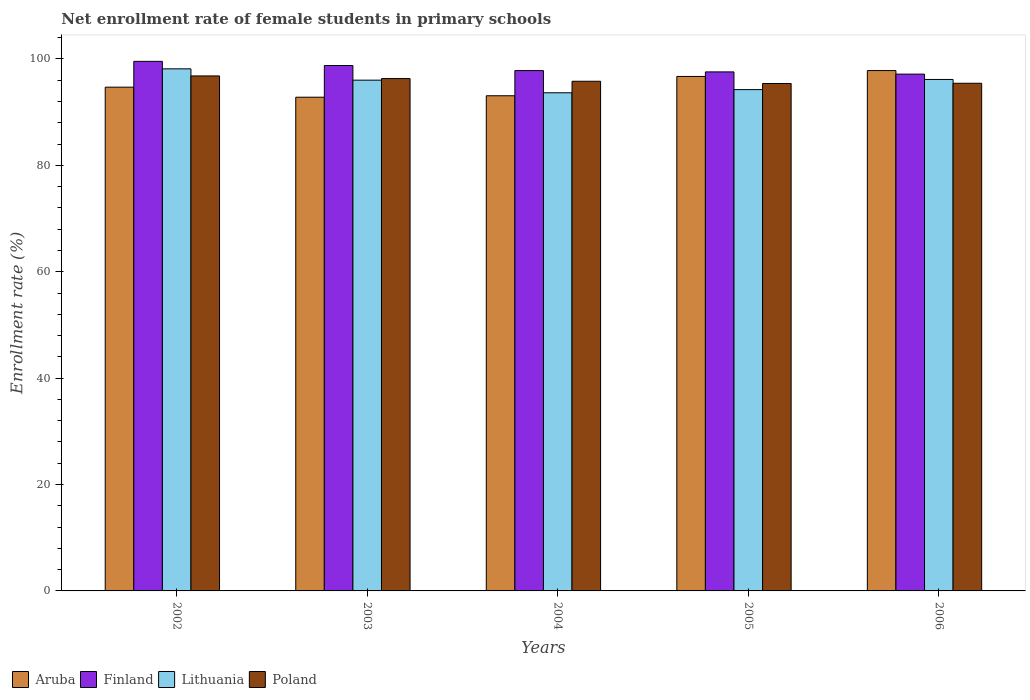How many different coloured bars are there?
Provide a short and direct response. 4. How many groups of bars are there?
Your answer should be compact. 5. Are the number of bars per tick equal to the number of legend labels?
Provide a succinct answer. Yes. Are the number of bars on each tick of the X-axis equal?
Provide a short and direct response. Yes. In how many cases, is the number of bars for a given year not equal to the number of legend labels?
Your answer should be compact. 0. What is the net enrollment rate of female students in primary schools in Poland in 2003?
Ensure brevity in your answer.  96.31. Across all years, what is the maximum net enrollment rate of female students in primary schools in Lithuania?
Give a very brief answer. 98.15. Across all years, what is the minimum net enrollment rate of female students in primary schools in Finland?
Give a very brief answer. 97.15. In which year was the net enrollment rate of female students in primary schools in Poland maximum?
Your response must be concise. 2002. In which year was the net enrollment rate of female students in primary schools in Aruba minimum?
Provide a succinct answer. 2003. What is the total net enrollment rate of female students in primary schools in Aruba in the graph?
Provide a short and direct response. 475.13. What is the difference between the net enrollment rate of female students in primary schools in Poland in 2004 and that in 2006?
Offer a terse response. 0.38. What is the difference between the net enrollment rate of female students in primary schools in Finland in 2003 and the net enrollment rate of female students in primary schools in Lithuania in 2006?
Offer a terse response. 2.62. What is the average net enrollment rate of female students in primary schools in Lithuania per year?
Offer a very short reply. 95.64. In the year 2005, what is the difference between the net enrollment rate of female students in primary schools in Aruba and net enrollment rate of female students in primary schools in Lithuania?
Make the answer very short. 2.48. In how many years, is the net enrollment rate of female students in primary schools in Finland greater than 20 %?
Your response must be concise. 5. What is the ratio of the net enrollment rate of female students in primary schools in Poland in 2004 to that in 2006?
Provide a succinct answer. 1. Is the net enrollment rate of female students in primary schools in Finland in 2002 less than that in 2006?
Provide a succinct answer. No. What is the difference between the highest and the second highest net enrollment rate of female students in primary schools in Finland?
Make the answer very short. 0.79. What is the difference between the highest and the lowest net enrollment rate of female students in primary schools in Finland?
Your answer should be very brief. 2.4. Is the sum of the net enrollment rate of female students in primary schools in Finland in 2002 and 2003 greater than the maximum net enrollment rate of female students in primary schools in Lithuania across all years?
Make the answer very short. Yes. Is it the case that in every year, the sum of the net enrollment rate of female students in primary schools in Aruba and net enrollment rate of female students in primary schools in Finland is greater than the sum of net enrollment rate of female students in primary schools in Poland and net enrollment rate of female students in primary schools in Lithuania?
Make the answer very short. Yes. What does the 1st bar from the left in 2005 represents?
Give a very brief answer. Aruba. Is it the case that in every year, the sum of the net enrollment rate of female students in primary schools in Lithuania and net enrollment rate of female students in primary schools in Aruba is greater than the net enrollment rate of female students in primary schools in Finland?
Keep it short and to the point. Yes. How many bars are there?
Your response must be concise. 20. What is the difference between two consecutive major ticks on the Y-axis?
Keep it short and to the point. 20. Does the graph contain grids?
Keep it short and to the point. No. Where does the legend appear in the graph?
Keep it short and to the point. Bottom left. How are the legend labels stacked?
Give a very brief answer. Horizontal. What is the title of the graph?
Your response must be concise. Net enrollment rate of female students in primary schools. Does "Equatorial Guinea" appear as one of the legend labels in the graph?
Provide a succinct answer. No. What is the label or title of the X-axis?
Make the answer very short. Years. What is the label or title of the Y-axis?
Offer a very short reply. Enrollment rate (%). What is the Enrollment rate (%) in Aruba in 2002?
Provide a short and direct response. 94.7. What is the Enrollment rate (%) of Finland in 2002?
Your answer should be very brief. 99.55. What is the Enrollment rate (%) of Lithuania in 2002?
Ensure brevity in your answer.  98.15. What is the Enrollment rate (%) of Poland in 2002?
Your response must be concise. 96.81. What is the Enrollment rate (%) of Aruba in 2003?
Offer a very short reply. 92.81. What is the Enrollment rate (%) of Finland in 2003?
Keep it short and to the point. 98.77. What is the Enrollment rate (%) of Lithuania in 2003?
Give a very brief answer. 96.02. What is the Enrollment rate (%) in Poland in 2003?
Offer a very short reply. 96.31. What is the Enrollment rate (%) of Aruba in 2004?
Offer a terse response. 93.08. What is the Enrollment rate (%) of Finland in 2004?
Offer a very short reply. 97.82. What is the Enrollment rate (%) in Lithuania in 2004?
Make the answer very short. 93.65. What is the Enrollment rate (%) of Poland in 2004?
Your answer should be very brief. 95.81. What is the Enrollment rate (%) in Aruba in 2005?
Your answer should be compact. 96.72. What is the Enrollment rate (%) in Finland in 2005?
Make the answer very short. 97.57. What is the Enrollment rate (%) of Lithuania in 2005?
Ensure brevity in your answer.  94.24. What is the Enrollment rate (%) in Poland in 2005?
Provide a succinct answer. 95.39. What is the Enrollment rate (%) of Aruba in 2006?
Your answer should be very brief. 97.82. What is the Enrollment rate (%) of Finland in 2006?
Your answer should be very brief. 97.15. What is the Enrollment rate (%) of Lithuania in 2006?
Provide a succinct answer. 96.15. What is the Enrollment rate (%) in Poland in 2006?
Provide a succinct answer. 95.43. Across all years, what is the maximum Enrollment rate (%) in Aruba?
Ensure brevity in your answer.  97.82. Across all years, what is the maximum Enrollment rate (%) in Finland?
Provide a succinct answer. 99.55. Across all years, what is the maximum Enrollment rate (%) of Lithuania?
Provide a succinct answer. 98.15. Across all years, what is the maximum Enrollment rate (%) in Poland?
Provide a short and direct response. 96.81. Across all years, what is the minimum Enrollment rate (%) of Aruba?
Give a very brief answer. 92.81. Across all years, what is the minimum Enrollment rate (%) in Finland?
Ensure brevity in your answer.  97.15. Across all years, what is the minimum Enrollment rate (%) of Lithuania?
Keep it short and to the point. 93.65. Across all years, what is the minimum Enrollment rate (%) in Poland?
Give a very brief answer. 95.39. What is the total Enrollment rate (%) in Aruba in the graph?
Provide a short and direct response. 475.13. What is the total Enrollment rate (%) in Finland in the graph?
Offer a terse response. 490.86. What is the total Enrollment rate (%) of Lithuania in the graph?
Your response must be concise. 478.19. What is the total Enrollment rate (%) in Poland in the graph?
Your answer should be very brief. 479.76. What is the difference between the Enrollment rate (%) in Aruba in 2002 and that in 2003?
Make the answer very short. 1.89. What is the difference between the Enrollment rate (%) of Finland in 2002 and that in 2003?
Your answer should be very brief. 0.79. What is the difference between the Enrollment rate (%) of Lithuania in 2002 and that in 2003?
Your answer should be compact. 2.13. What is the difference between the Enrollment rate (%) of Poland in 2002 and that in 2003?
Ensure brevity in your answer.  0.5. What is the difference between the Enrollment rate (%) of Aruba in 2002 and that in 2004?
Your answer should be compact. 1.62. What is the difference between the Enrollment rate (%) of Finland in 2002 and that in 2004?
Make the answer very short. 1.74. What is the difference between the Enrollment rate (%) of Lithuania in 2002 and that in 2004?
Make the answer very short. 4.5. What is the difference between the Enrollment rate (%) of Aruba in 2002 and that in 2005?
Offer a very short reply. -2.02. What is the difference between the Enrollment rate (%) of Finland in 2002 and that in 2005?
Make the answer very short. 1.98. What is the difference between the Enrollment rate (%) of Lithuania in 2002 and that in 2005?
Give a very brief answer. 3.91. What is the difference between the Enrollment rate (%) of Poland in 2002 and that in 2005?
Ensure brevity in your answer.  1.42. What is the difference between the Enrollment rate (%) in Aruba in 2002 and that in 2006?
Your response must be concise. -3.12. What is the difference between the Enrollment rate (%) in Finland in 2002 and that in 2006?
Provide a succinct answer. 2.4. What is the difference between the Enrollment rate (%) in Lithuania in 2002 and that in 2006?
Ensure brevity in your answer.  2. What is the difference between the Enrollment rate (%) in Poland in 2002 and that in 2006?
Keep it short and to the point. 1.38. What is the difference between the Enrollment rate (%) in Aruba in 2003 and that in 2004?
Your answer should be compact. -0.27. What is the difference between the Enrollment rate (%) in Finland in 2003 and that in 2004?
Give a very brief answer. 0.95. What is the difference between the Enrollment rate (%) of Lithuania in 2003 and that in 2004?
Provide a succinct answer. 2.37. What is the difference between the Enrollment rate (%) in Poland in 2003 and that in 2004?
Make the answer very short. 0.5. What is the difference between the Enrollment rate (%) of Aruba in 2003 and that in 2005?
Keep it short and to the point. -3.9. What is the difference between the Enrollment rate (%) of Finland in 2003 and that in 2005?
Your answer should be compact. 1.2. What is the difference between the Enrollment rate (%) in Lithuania in 2003 and that in 2005?
Provide a short and direct response. 1.78. What is the difference between the Enrollment rate (%) of Poland in 2003 and that in 2005?
Make the answer very short. 0.92. What is the difference between the Enrollment rate (%) in Aruba in 2003 and that in 2006?
Make the answer very short. -5.01. What is the difference between the Enrollment rate (%) in Finland in 2003 and that in 2006?
Provide a succinct answer. 1.61. What is the difference between the Enrollment rate (%) in Lithuania in 2003 and that in 2006?
Give a very brief answer. -0.13. What is the difference between the Enrollment rate (%) in Poland in 2003 and that in 2006?
Keep it short and to the point. 0.88. What is the difference between the Enrollment rate (%) of Aruba in 2004 and that in 2005?
Your answer should be very brief. -3.63. What is the difference between the Enrollment rate (%) of Finland in 2004 and that in 2005?
Provide a succinct answer. 0.24. What is the difference between the Enrollment rate (%) in Lithuania in 2004 and that in 2005?
Offer a very short reply. -0.59. What is the difference between the Enrollment rate (%) of Poland in 2004 and that in 2005?
Give a very brief answer. 0.42. What is the difference between the Enrollment rate (%) of Aruba in 2004 and that in 2006?
Make the answer very short. -4.74. What is the difference between the Enrollment rate (%) of Finland in 2004 and that in 2006?
Your answer should be compact. 0.66. What is the difference between the Enrollment rate (%) of Lithuania in 2004 and that in 2006?
Your answer should be very brief. -2.5. What is the difference between the Enrollment rate (%) in Poland in 2004 and that in 2006?
Your response must be concise. 0.38. What is the difference between the Enrollment rate (%) of Aruba in 2005 and that in 2006?
Keep it short and to the point. -1.1. What is the difference between the Enrollment rate (%) of Finland in 2005 and that in 2006?
Provide a short and direct response. 0.42. What is the difference between the Enrollment rate (%) in Lithuania in 2005 and that in 2006?
Provide a succinct answer. -1.91. What is the difference between the Enrollment rate (%) in Poland in 2005 and that in 2006?
Offer a very short reply. -0.04. What is the difference between the Enrollment rate (%) in Aruba in 2002 and the Enrollment rate (%) in Finland in 2003?
Give a very brief answer. -4.07. What is the difference between the Enrollment rate (%) in Aruba in 2002 and the Enrollment rate (%) in Lithuania in 2003?
Keep it short and to the point. -1.32. What is the difference between the Enrollment rate (%) in Aruba in 2002 and the Enrollment rate (%) in Poland in 2003?
Keep it short and to the point. -1.61. What is the difference between the Enrollment rate (%) in Finland in 2002 and the Enrollment rate (%) in Lithuania in 2003?
Your response must be concise. 3.54. What is the difference between the Enrollment rate (%) in Finland in 2002 and the Enrollment rate (%) in Poland in 2003?
Offer a terse response. 3.24. What is the difference between the Enrollment rate (%) in Lithuania in 2002 and the Enrollment rate (%) in Poland in 2003?
Your response must be concise. 1.83. What is the difference between the Enrollment rate (%) of Aruba in 2002 and the Enrollment rate (%) of Finland in 2004?
Provide a succinct answer. -3.12. What is the difference between the Enrollment rate (%) in Aruba in 2002 and the Enrollment rate (%) in Lithuania in 2004?
Your answer should be very brief. 1.05. What is the difference between the Enrollment rate (%) of Aruba in 2002 and the Enrollment rate (%) of Poland in 2004?
Keep it short and to the point. -1.11. What is the difference between the Enrollment rate (%) in Finland in 2002 and the Enrollment rate (%) in Lithuania in 2004?
Offer a terse response. 5.91. What is the difference between the Enrollment rate (%) in Finland in 2002 and the Enrollment rate (%) in Poland in 2004?
Give a very brief answer. 3.74. What is the difference between the Enrollment rate (%) in Lithuania in 2002 and the Enrollment rate (%) in Poland in 2004?
Ensure brevity in your answer.  2.33. What is the difference between the Enrollment rate (%) of Aruba in 2002 and the Enrollment rate (%) of Finland in 2005?
Your answer should be compact. -2.87. What is the difference between the Enrollment rate (%) of Aruba in 2002 and the Enrollment rate (%) of Lithuania in 2005?
Provide a short and direct response. 0.46. What is the difference between the Enrollment rate (%) in Aruba in 2002 and the Enrollment rate (%) in Poland in 2005?
Keep it short and to the point. -0.69. What is the difference between the Enrollment rate (%) of Finland in 2002 and the Enrollment rate (%) of Lithuania in 2005?
Offer a terse response. 5.31. What is the difference between the Enrollment rate (%) of Finland in 2002 and the Enrollment rate (%) of Poland in 2005?
Offer a terse response. 4.16. What is the difference between the Enrollment rate (%) in Lithuania in 2002 and the Enrollment rate (%) in Poland in 2005?
Offer a terse response. 2.76. What is the difference between the Enrollment rate (%) in Aruba in 2002 and the Enrollment rate (%) in Finland in 2006?
Give a very brief answer. -2.45. What is the difference between the Enrollment rate (%) in Aruba in 2002 and the Enrollment rate (%) in Lithuania in 2006?
Offer a terse response. -1.45. What is the difference between the Enrollment rate (%) in Aruba in 2002 and the Enrollment rate (%) in Poland in 2006?
Give a very brief answer. -0.73. What is the difference between the Enrollment rate (%) in Finland in 2002 and the Enrollment rate (%) in Lithuania in 2006?
Your answer should be very brief. 3.4. What is the difference between the Enrollment rate (%) of Finland in 2002 and the Enrollment rate (%) of Poland in 2006?
Your answer should be very brief. 4.12. What is the difference between the Enrollment rate (%) in Lithuania in 2002 and the Enrollment rate (%) in Poland in 2006?
Your answer should be compact. 2.71. What is the difference between the Enrollment rate (%) in Aruba in 2003 and the Enrollment rate (%) in Finland in 2004?
Your response must be concise. -5. What is the difference between the Enrollment rate (%) in Aruba in 2003 and the Enrollment rate (%) in Lithuania in 2004?
Offer a terse response. -0.83. What is the difference between the Enrollment rate (%) of Aruba in 2003 and the Enrollment rate (%) of Poland in 2004?
Offer a very short reply. -3. What is the difference between the Enrollment rate (%) of Finland in 2003 and the Enrollment rate (%) of Lithuania in 2004?
Provide a succinct answer. 5.12. What is the difference between the Enrollment rate (%) of Finland in 2003 and the Enrollment rate (%) of Poland in 2004?
Your answer should be very brief. 2.96. What is the difference between the Enrollment rate (%) of Lithuania in 2003 and the Enrollment rate (%) of Poland in 2004?
Keep it short and to the point. 0.2. What is the difference between the Enrollment rate (%) of Aruba in 2003 and the Enrollment rate (%) of Finland in 2005?
Your response must be concise. -4.76. What is the difference between the Enrollment rate (%) of Aruba in 2003 and the Enrollment rate (%) of Lithuania in 2005?
Provide a succinct answer. -1.43. What is the difference between the Enrollment rate (%) in Aruba in 2003 and the Enrollment rate (%) in Poland in 2005?
Offer a very short reply. -2.58. What is the difference between the Enrollment rate (%) in Finland in 2003 and the Enrollment rate (%) in Lithuania in 2005?
Your answer should be very brief. 4.53. What is the difference between the Enrollment rate (%) of Finland in 2003 and the Enrollment rate (%) of Poland in 2005?
Provide a short and direct response. 3.38. What is the difference between the Enrollment rate (%) in Lithuania in 2003 and the Enrollment rate (%) in Poland in 2005?
Keep it short and to the point. 0.63. What is the difference between the Enrollment rate (%) of Aruba in 2003 and the Enrollment rate (%) of Finland in 2006?
Your response must be concise. -4.34. What is the difference between the Enrollment rate (%) in Aruba in 2003 and the Enrollment rate (%) in Lithuania in 2006?
Your answer should be very brief. -3.34. What is the difference between the Enrollment rate (%) in Aruba in 2003 and the Enrollment rate (%) in Poland in 2006?
Your answer should be very brief. -2.62. What is the difference between the Enrollment rate (%) in Finland in 2003 and the Enrollment rate (%) in Lithuania in 2006?
Offer a terse response. 2.62. What is the difference between the Enrollment rate (%) in Finland in 2003 and the Enrollment rate (%) in Poland in 2006?
Give a very brief answer. 3.33. What is the difference between the Enrollment rate (%) of Lithuania in 2003 and the Enrollment rate (%) of Poland in 2006?
Offer a terse response. 0.58. What is the difference between the Enrollment rate (%) of Aruba in 2004 and the Enrollment rate (%) of Finland in 2005?
Your answer should be very brief. -4.49. What is the difference between the Enrollment rate (%) of Aruba in 2004 and the Enrollment rate (%) of Lithuania in 2005?
Keep it short and to the point. -1.15. What is the difference between the Enrollment rate (%) in Aruba in 2004 and the Enrollment rate (%) in Poland in 2005?
Make the answer very short. -2.31. What is the difference between the Enrollment rate (%) of Finland in 2004 and the Enrollment rate (%) of Lithuania in 2005?
Offer a terse response. 3.58. What is the difference between the Enrollment rate (%) in Finland in 2004 and the Enrollment rate (%) in Poland in 2005?
Make the answer very short. 2.43. What is the difference between the Enrollment rate (%) in Lithuania in 2004 and the Enrollment rate (%) in Poland in 2005?
Provide a succinct answer. -1.75. What is the difference between the Enrollment rate (%) of Aruba in 2004 and the Enrollment rate (%) of Finland in 2006?
Offer a very short reply. -4.07. What is the difference between the Enrollment rate (%) in Aruba in 2004 and the Enrollment rate (%) in Lithuania in 2006?
Offer a very short reply. -3.07. What is the difference between the Enrollment rate (%) of Aruba in 2004 and the Enrollment rate (%) of Poland in 2006?
Give a very brief answer. -2.35. What is the difference between the Enrollment rate (%) in Finland in 2004 and the Enrollment rate (%) in Lithuania in 2006?
Keep it short and to the point. 1.67. What is the difference between the Enrollment rate (%) in Finland in 2004 and the Enrollment rate (%) in Poland in 2006?
Your answer should be compact. 2.38. What is the difference between the Enrollment rate (%) in Lithuania in 2004 and the Enrollment rate (%) in Poland in 2006?
Your response must be concise. -1.79. What is the difference between the Enrollment rate (%) of Aruba in 2005 and the Enrollment rate (%) of Finland in 2006?
Offer a very short reply. -0.44. What is the difference between the Enrollment rate (%) in Aruba in 2005 and the Enrollment rate (%) in Lithuania in 2006?
Give a very brief answer. 0.57. What is the difference between the Enrollment rate (%) of Aruba in 2005 and the Enrollment rate (%) of Poland in 2006?
Make the answer very short. 1.28. What is the difference between the Enrollment rate (%) of Finland in 2005 and the Enrollment rate (%) of Lithuania in 2006?
Offer a very short reply. 1.42. What is the difference between the Enrollment rate (%) in Finland in 2005 and the Enrollment rate (%) in Poland in 2006?
Make the answer very short. 2.14. What is the difference between the Enrollment rate (%) in Lithuania in 2005 and the Enrollment rate (%) in Poland in 2006?
Your answer should be very brief. -1.2. What is the average Enrollment rate (%) of Aruba per year?
Provide a short and direct response. 95.03. What is the average Enrollment rate (%) in Finland per year?
Offer a terse response. 98.17. What is the average Enrollment rate (%) of Lithuania per year?
Offer a terse response. 95.64. What is the average Enrollment rate (%) of Poland per year?
Keep it short and to the point. 95.95. In the year 2002, what is the difference between the Enrollment rate (%) in Aruba and Enrollment rate (%) in Finland?
Make the answer very short. -4.85. In the year 2002, what is the difference between the Enrollment rate (%) of Aruba and Enrollment rate (%) of Lithuania?
Make the answer very short. -3.45. In the year 2002, what is the difference between the Enrollment rate (%) of Aruba and Enrollment rate (%) of Poland?
Provide a succinct answer. -2.11. In the year 2002, what is the difference between the Enrollment rate (%) of Finland and Enrollment rate (%) of Lithuania?
Give a very brief answer. 1.41. In the year 2002, what is the difference between the Enrollment rate (%) of Finland and Enrollment rate (%) of Poland?
Offer a very short reply. 2.74. In the year 2002, what is the difference between the Enrollment rate (%) of Lithuania and Enrollment rate (%) of Poland?
Your answer should be compact. 1.33. In the year 2003, what is the difference between the Enrollment rate (%) of Aruba and Enrollment rate (%) of Finland?
Provide a succinct answer. -5.95. In the year 2003, what is the difference between the Enrollment rate (%) of Aruba and Enrollment rate (%) of Lithuania?
Your answer should be compact. -3.2. In the year 2003, what is the difference between the Enrollment rate (%) in Aruba and Enrollment rate (%) in Poland?
Your response must be concise. -3.5. In the year 2003, what is the difference between the Enrollment rate (%) of Finland and Enrollment rate (%) of Lithuania?
Your answer should be compact. 2.75. In the year 2003, what is the difference between the Enrollment rate (%) of Finland and Enrollment rate (%) of Poland?
Ensure brevity in your answer.  2.45. In the year 2003, what is the difference between the Enrollment rate (%) in Lithuania and Enrollment rate (%) in Poland?
Keep it short and to the point. -0.3. In the year 2004, what is the difference between the Enrollment rate (%) of Aruba and Enrollment rate (%) of Finland?
Offer a very short reply. -4.73. In the year 2004, what is the difference between the Enrollment rate (%) of Aruba and Enrollment rate (%) of Lithuania?
Offer a very short reply. -0.56. In the year 2004, what is the difference between the Enrollment rate (%) of Aruba and Enrollment rate (%) of Poland?
Keep it short and to the point. -2.73. In the year 2004, what is the difference between the Enrollment rate (%) of Finland and Enrollment rate (%) of Lithuania?
Ensure brevity in your answer.  4.17. In the year 2004, what is the difference between the Enrollment rate (%) in Finland and Enrollment rate (%) in Poland?
Provide a succinct answer. 2. In the year 2004, what is the difference between the Enrollment rate (%) in Lithuania and Enrollment rate (%) in Poland?
Your response must be concise. -2.17. In the year 2005, what is the difference between the Enrollment rate (%) of Aruba and Enrollment rate (%) of Finland?
Ensure brevity in your answer.  -0.86. In the year 2005, what is the difference between the Enrollment rate (%) of Aruba and Enrollment rate (%) of Lithuania?
Ensure brevity in your answer.  2.48. In the year 2005, what is the difference between the Enrollment rate (%) in Aruba and Enrollment rate (%) in Poland?
Offer a very short reply. 1.32. In the year 2005, what is the difference between the Enrollment rate (%) of Finland and Enrollment rate (%) of Lithuania?
Provide a succinct answer. 3.33. In the year 2005, what is the difference between the Enrollment rate (%) in Finland and Enrollment rate (%) in Poland?
Your answer should be very brief. 2.18. In the year 2005, what is the difference between the Enrollment rate (%) of Lithuania and Enrollment rate (%) of Poland?
Offer a terse response. -1.15. In the year 2006, what is the difference between the Enrollment rate (%) of Aruba and Enrollment rate (%) of Finland?
Give a very brief answer. 0.67. In the year 2006, what is the difference between the Enrollment rate (%) in Aruba and Enrollment rate (%) in Lithuania?
Your answer should be compact. 1.67. In the year 2006, what is the difference between the Enrollment rate (%) of Aruba and Enrollment rate (%) of Poland?
Make the answer very short. 2.39. In the year 2006, what is the difference between the Enrollment rate (%) of Finland and Enrollment rate (%) of Lithuania?
Offer a terse response. 1. In the year 2006, what is the difference between the Enrollment rate (%) in Finland and Enrollment rate (%) in Poland?
Ensure brevity in your answer.  1.72. In the year 2006, what is the difference between the Enrollment rate (%) of Lithuania and Enrollment rate (%) of Poland?
Ensure brevity in your answer.  0.72. What is the ratio of the Enrollment rate (%) in Aruba in 2002 to that in 2003?
Make the answer very short. 1.02. What is the ratio of the Enrollment rate (%) of Lithuania in 2002 to that in 2003?
Your response must be concise. 1.02. What is the ratio of the Enrollment rate (%) in Poland in 2002 to that in 2003?
Ensure brevity in your answer.  1.01. What is the ratio of the Enrollment rate (%) of Aruba in 2002 to that in 2004?
Make the answer very short. 1.02. What is the ratio of the Enrollment rate (%) of Finland in 2002 to that in 2004?
Ensure brevity in your answer.  1.02. What is the ratio of the Enrollment rate (%) in Lithuania in 2002 to that in 2004?
Provide a short and direct response. 1.05. What is the ratio of the Enrollment rate (%) in Poland in 2002 to that in 2004?
Give a very brief answer. 1.01. What is the ratio of the Enrollment rate (%) of Aruba in 2002 to that in 2005?
Offer a terse response. 0.98. What is the ratio of the Enrollment rate (%) in Finland in 2002 to that in 2005?
Your response must be concise. 1.02. What is the ratio of the Enrollment rate (%) in Lithuania in 2002 to that in 2005?
Your answer should be very brief. 1.04. What is the ratio of the Enrollment rate (%) in Poland in 2002 to that in 2005?
Offer a very short reply. 1.01. What is the ratio of the Enrollment rate (%) in Aruba in 2002 to that in 2006?
Provide a short and direct response. 0.97. What is the ratio of the Enrollment rate (%) of Finland in 2002 to that in 2006?
Your answer should be very brief. 1.02. What is the ratio of the Enrollment rate (%) of Lithuania in 2002 to that in 2006?
Your answer should be compact. 1.02. What is the ratio of the Enrollment rate (%) of Poland in 2002 to that in 2006?
Offer a very short reply. 1.01. What is the ratio of the Enrollment rate (%) in Finland in 2003 to that in 2004?
Keep it short and to the point. 1.01. What is the ratio of the Enrollment rate (%) of Lithuania in 2003 to that in 2004?
Your response must be concise. 1.03. What is the ratio of the Enrollment rate (%) in Poland in 2003 to that in 2004?
Your answer should be compact. 1.01. What is the ratio of the Enrollment rate (%) in Aruba in 2003 to that in 2005?
Offer a very short reply. 0.96. What is the ratio of the Enrollment rate (%) of Finland in 2003 to that in 2005?
Provide a succinct answer. 1.01. What is the ratio of the Enrollment rate (%) in Lithuania in 2003 to that in 2005?
Offer a very short reply. 1.02. What is the ratio of the Enrollment rate (%) of Poland in 2003 to that in 2005?
Your answer should be compact. 1.01. What is the ratio of the Enrollment rate (%) of Aruba in 2003 to that in 2006?
Keep it short and to the point. 0.95. What is the ratio of the Enrollment rate (%) in Finland in 2003 to that in 2006?
Ensure brevity in your answer.  1.02. What is the ratio of the Enrollment rate (%) in Poland in 2003 to that in 2006?
Make the answer very short. 1.01. What is the ratio of the Enrollment rate (%) in Aruba in 2004 to that in 2005?
Provide a short and direct response. 0.96. What is the ratio of the Enrollment rate (%) in Finland in 2004 to that in 2005?
Your response must be concise. 1. What is the ratio of the Enrollment rate (%) in Lithuania in 2004 to that in 2005?
Ensure brevity in your answer.  0.99. What is the ratio of the Enrollment rate (%) in Poland in 2004 to that in 2005?
Provide a short and direct response. 1. What is the ratio of the Enrollment rate (%) in Aruba in 2004 to that in 2006?
Offer a terse response. 0.95. What is the ratio of the Enrollment rate (%) in Finland in 2004 to that in 2006?
Your response must be concise. 1.01. What is the ratio of the Enrollment rate (%) in Poland in 2004 to that in 2006?
Make the answer very short. 1. What is the ratio of the Enrollment rate (%) of Aruba in 2005 to that in 2006?
Offer a terse response. 0.99. What is the ratio of the Enrollment rate (%) in Lithuania in 2005 to that in 2006?
Provide a short and direct response. 0.98. What is the difference between the highest and the second highest Enrollment rate (%) of Aruba?
Your answer should be very brief. 1.1. What is the difference between the highest and the second highest Enrollment rate (%) in Finland?
Your response must be concise. 0.79. What is the difference between the highest and the second highest Enrollment rate (%) in Lithuania?
Make the answer very short. 2. What is the difference between the highest and the second highest Enrollment rate (%) in Poland?
Your answer should be very brief. 0.5. What is the difference between the highest and the lowest Enrollment rate (%) of Aruba?
Provide a succinct answer. 5.01. What is the difference between the highest and the lowest Enrollment rate (%) of Finland?
Keep it short and to the point. 2.4. What is the difference between the highest and the lowest Enrollment rate (%) in Lithuania?
Provide a succinct answer. 4.5. What is the difference between the highest and the lowest Enrollment rate (%) in Poland?
Your answer should be very brief. 1.42. 